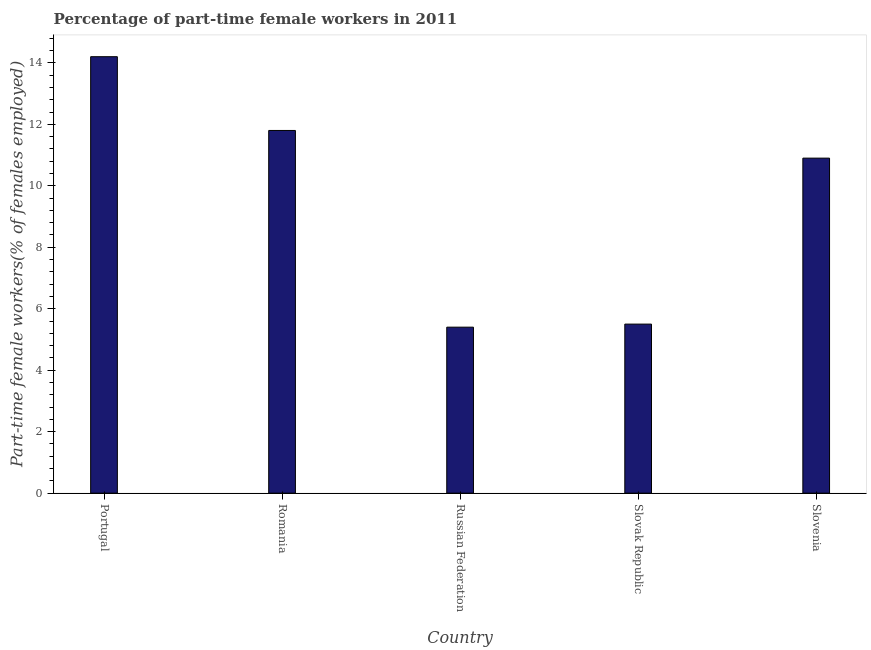Does the graph contain grids?
Offer a terse response. No. What is the title of the graph?
Your answer should be very brief. Percentage of part-time female workers in 2011. What is the label or title of the Y-axis?
Ensure brevity in your answer.  Part-time female workers(% of females employed). Across all countries, what is the maximum percentage of part-time female workers?
Offer a very short reply. 14.2. Across all countries, what is the minimum percentage of part-time female workers?
Your answer should be compact. 5.4. In which country was the percentage of part-time female workers maximum?
Provide a succinct answer. Portugal. In which country was the percentage of part-time female workers minimum?
Keep it short and to the point. Russian Federation. What is the sum of the percentage of part-time female workers?
Provide a succinct answer. 47.8. What is the average percentage of part-time female workers per country?
Keep it short and to the point. 9.56. What is the median percentage of part-time female workers?
Keep it short and to the point. 10.9. In how many countries, is the percentage of part-time female workers greater than 0.8 %?
Provide a succinct answer. 5. What is the ratio of the percentage of part-time female workers in Slovak Republic to that in Slovenia?
Provide a succinct answer. 0.51. Is the percentage of part-time female workers in Portugal less than that in Russian Federation?
Make the answer very short. No. In how many countries, is the percentage of part-time female workers greater than the average percentage of part-time female workers taken over all countries?
Offer a very short reply. 3. Are the values on the major ticks of Y-axis written in scientific E-notation?
Provide a short and direct response. No. What is the Part-time female workers(% of females employed) of Portugal?
Keep it short and to the point. 14.2. What is the Part-time female workers(% of females employed) in Romania?
Offer a terse response. 11.8. What is the Part-time female workers(% of females employed) in Russian Federation?
Keep it short and to the point. 5.4. What is the Part-time female workers(% of females employed) in Slovenia?
Offer a very short reply. 10.9. What is the difference between the Part-time female workers(% of females employed) in Portugal and Romania?
Give a very brief answer. 2.4. What is the difference between the Part-time female workers(% of females employed) in Portugal and Russian Federation?
Provide a short and direct response. 8.8. What is the difference between the Part-time female workers(% of females employed) in Portugal and Slovenia?
Offer a very short reply. 3.3. What is the difference between the Part-time female workers(% of females employed) in Romania and Slovak Republic?
Keep it short and to the point. 6.3. What is the difference between the Part-time female workers(% of females employed) in Romania and Slovenia?
Your response must be concise. 0.9. What is the difference between the Part-time female workers(% of females employed) in Russian Federation and Slovak Republic?
Your answer should be compact. -0.1. What is the ratio of the Part-time female workers(% of females employed) in Portugal to that in Romania?
Your response must be concise. 1.2. What is the ratio of the Part-time female workers(% of females employed) in Portugal to that in Russian Federation?
Your response must be concise. 2.63. What is the ratio of the Part-time female workers(% of females employed) in Portugal to that in Slovak Republic?
Provide a short and direct response. 2.58. What is the ratio of the Part-time female workers(% of females employed) in Portugal to that in Slovenia?
Offer a very short reply. 1.3. What is the ratio of the Part-time female workers(% of females employed) in Romania to that in Russian Federation?
Make the answer very short. 2.19. What is the ratio of the Part-time female workers(% of females employed) in Romania to that in Slovak Republic?
Offer a terse response. 2.15. What is the ratio of the Part-time female workers(% of females employed) in Romania to that in Slovenia?
Keep it short and to the point. 1.08. What is the ratio of the Part-time female workers(% of females employed) in Russian Federation to that in Slovak Republic?
Provide a short and direct response. 0.98. What is the ratio of the Part-time female workers(% of females employed) in Russian Federation to that in Slovenia?
Give a very brief answer. 0.49. What is the ratio of the Part-time female workers(% of females employed) in Slovak Republic to that in Slovenia?
Offer a very short reply. 0.51. 